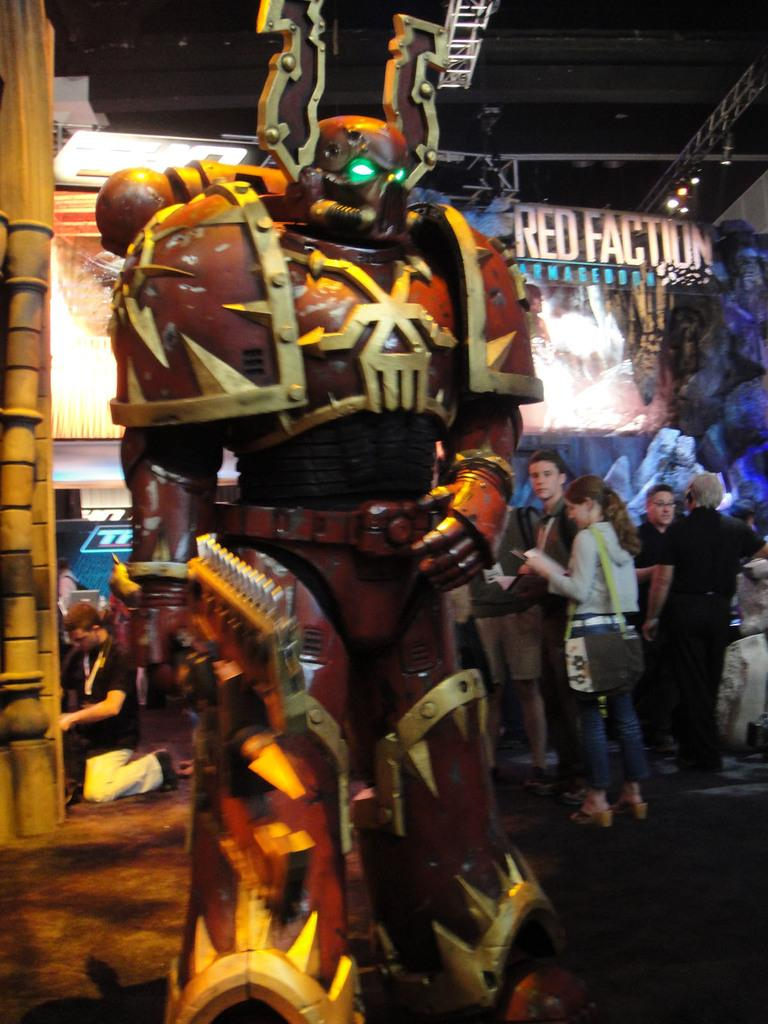What is the main subject of the image? There is a robot statue in the image. Are there any other people or objects in the image? Yes, there is a group of people and a screen visible in the image. What else can be seen in the image? There are banners in the image. What is visible at the top of the image? The sky is visible at the top of the image. How would you describe the lighting in the image? The image appears to be slightly dark. How many boys are holding hands with the robot statue in the image? There are no boys present in the image, and the robot statue is a statue, so it cannot hold hands. 